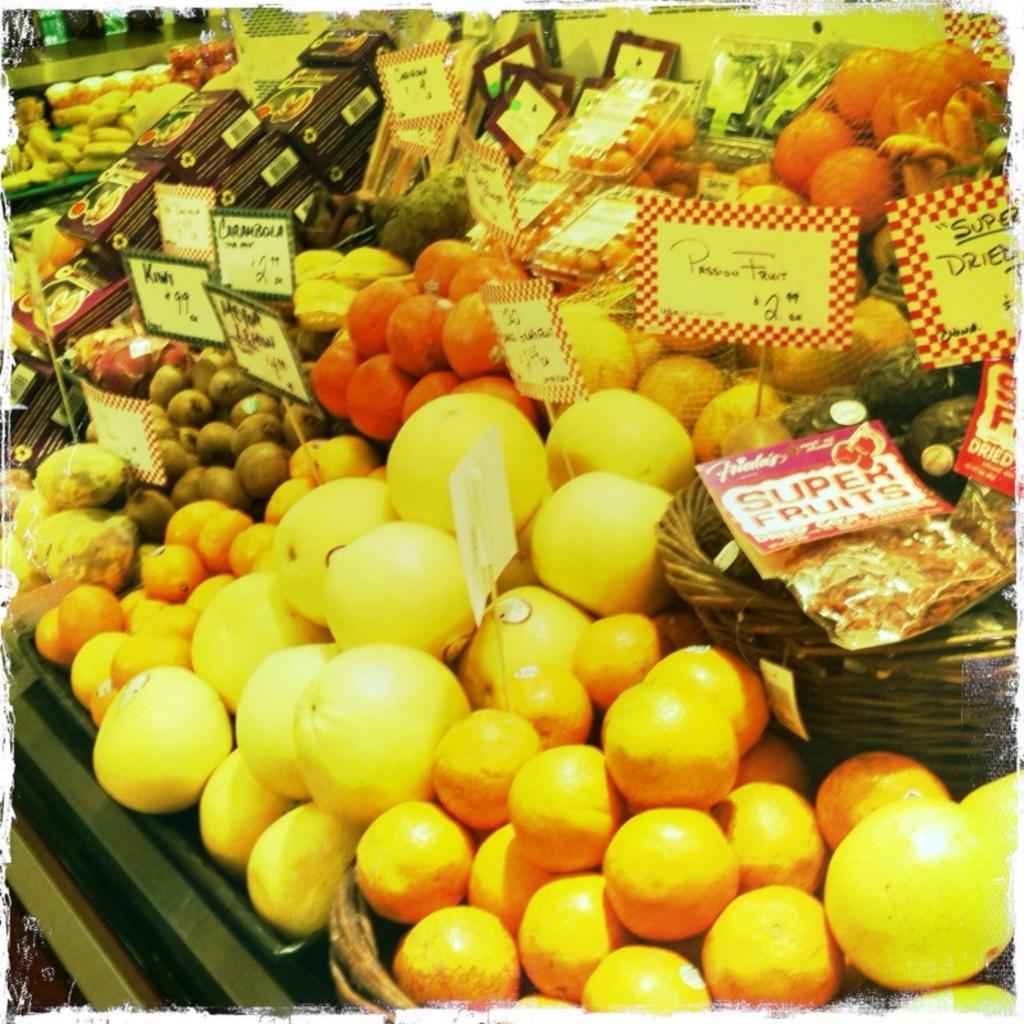Please provide a concise description of this image. In this image we can see different types of fruits with their name boards and other objects. 